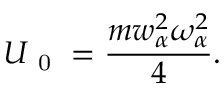Convert formula to latex. <formula><loc_0><loc_0><loc_500><loc_500>U _ { 0 } = \frac { m w _ { \alpha } ^ { 2 } \omega _ { \alpha } ^ { 2 } } { 4 } .</formula> 